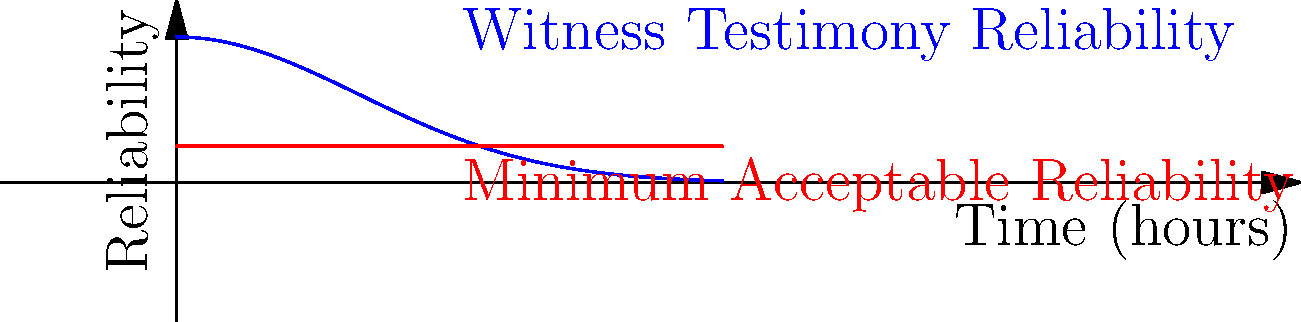In a criminal investigation, the reliability of witness testimony over time is modeled by the function $f(t) = 0.8e^{-0.5t^2}$, where $t$ is the time in hours since the incident occurred. The minimum acceptable reliability threshold is set at 0.2. Calculate the volume of the solid formed by rotating the region bounded by $f(t)$, the t-axis, and the line $t=3$ about the t-axis, but only considering the area where the witness testimony reliability is above the minimum threshold. To solve this problem, we'll follow these steps:

1) First, we need to find the intersection point of $f(t)$ and the minimum threshold line $y=0.2$. We can solve this equation:

   $0.8e^{-0.5t^2} = 0.2$

2) Solving this equation:
   $e^{-0.5t^2} = 0.25$
   $-0.5t^2 = \ln(0.25) = -1.386$
   $t^2 = 2.772$
   $t = \sqrt{2.772} \approx 1.665$

3) Now, we can set up the integral for the volume of revolution:

   $V = \pi \int_0^{1.665} (f(t))^2 dt$

4) Substituting the function:

   $V = \pi \int_0^{1.665} (0.8e^{-0.5t^2})^2 dt$

5) Simplifying:

   $V = 0.64\pi \int_0^{1.665} e^{-t^2} dt$

6) This integral doesn't have an elementary antiderivative. We need to use the error function erf(x):

   $V = 0.64\pi \cdot \frac{\sqrt{\pi}}{2} [\text{erf}(t)]_0^{1.665}$

7) Evaluating:

   $V = 0.32\pi^{3/2} [\text{erf}(1.665) - \text{erf}(0)]$

8) $\text{erf}(1.665) \approx 0.9764$ and $\text{erf}(0) = 0$

9) Therefore:

   $V \approx 0.32\pi^{3/2} \cdot 0.9764 \approx 0.9853$ cubic units
Answer: $0.9853$ cubic units 